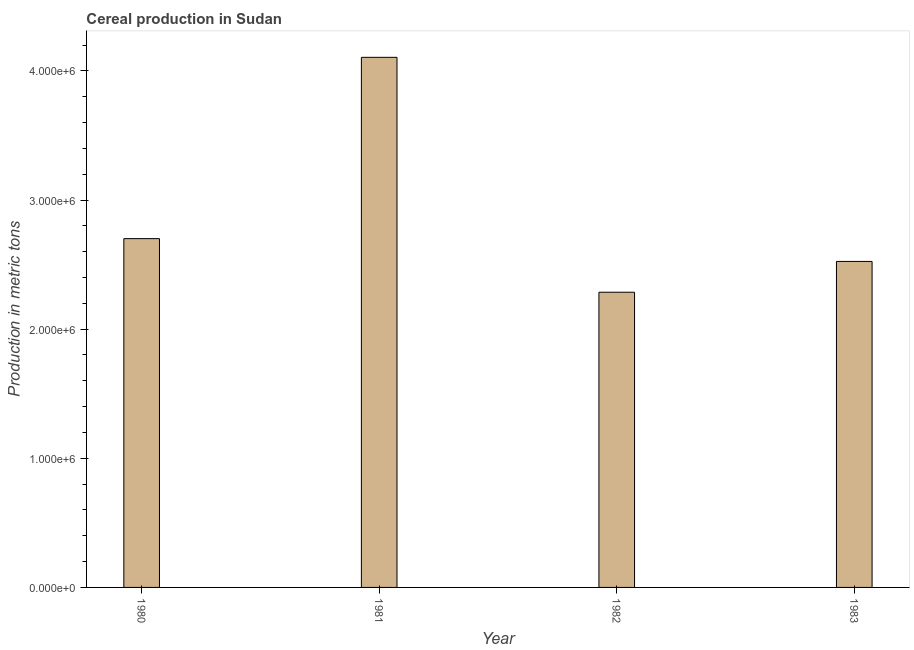Does the graph contain grids?
Offer a very short reply. No. What is the title of the graph?
Make the answer very short. Cereal production in Sudan. What is the label or title of the X-axis?
Make the answer very short. Year. What is the label or title of the Y-axis?
Provide a succinct answer. Production in metric tons. What is the cereal production in 1982?
Offer a very short reply. 2.29e+06. Across all years, what is the maximum cereal production?
Offer a very short reply. 4.10e+06. Across all years, what is the minimum cereal production?
Your answer should be very brief. 2.29e+06. What is the sum of the cereal production?
Keep it short and to the point. 1.16e+07. What is the difference between the cereal production in 1980 and 1983?
Offer a terse response. 1.76e+05. What is the average cereal production per year?
Offer a terse response. 2.90e+06. What is the median cereal production?
Provide a short and direct response. 2.61e+06. In how many years, is the cereal production greater than 1000000 metric tons?
Provide a short and direct response. 4. What is the ratio of the cereal production in 1982 to that in 1983?
Make the answer very short. 0.91. Is the difference between the cereal production in 1981 and 1982 greater than the difference between any two years?
Your response must be concise. Yes. What is the difference between the highest and the second highest cereal production?
Make the answer very short. 1.40e+06. Is the sum of the cereal production in 1981 and 1982 greater than the maximum cereal production across all years?
Keep it short and to the point. Yes. What is the difference between the highest and the lowest cereal production?
Provide a short and direct response. 1.82e+06. Are all the bars in the graph horizontal?
Ensure brevity in your answer.  No. How many years are there in the graph?
Keep it short and to the point. 4. Are the values on the major ticks of Y-axis written in scientific E-notation?
Your response must be concise. Yes. What is the Production in metric tons in 1980?
Give a very brief answer. 2.70e+06. What is the Production in metric tons in 1981?
Your response must be concise. 4.10e+06. What is the Production in metric tons in 1982?
Offer a terse response. 2.29e+06. What is the Production in metric tons of 1983?
Ensure brevity in your answer.  2.52e+06. What is the difference between the Production in metric tons in 1980 and 1981?
Your response must be concise. -1.40e+06. What is the difference between the Production in metric tons in 1980 and 1982?
Ensure brevity in your answer.  4.15e+05. What is the difference between the Production in metric tons in 1980 and 1983?
Make the answer very short. 1.76e+05. What is the difference between the Production in metric tons in 1981 and 1982?
Offer a terse response. 1.82e+06. What is the difference between the Production in metric tons in 1981 and 1983?
Make the answer very short. 1.58e+06. What is the difference between the Production in metric tons in 1982 and 1983?
Your answer should be compact. -2.38e+05. What is the ratio of the Production in metric tons in 1980 to that in 1981?
Keep it short and to the point. 0.66. What is the ratio of the Production in metric tons in 1980 to that in 1982?
Ensure brevity in your answer.  1.18. What is the ratio of the Production in metric tons in 1980 to that in 1983?
Offer a very short reply. 1.07. What is the ratio of the Production in metric tons in 1981 to that in 1982?
Provide a short and direct response. 1.8. What is the ratio of the Production in metric tons in 1981 to that in 1983?
Ensure brevity in your answer.  1.63. What is the ratio of the Production in metric tons in 1982 to that in 1983?
Your response must be concise. 0.91. 